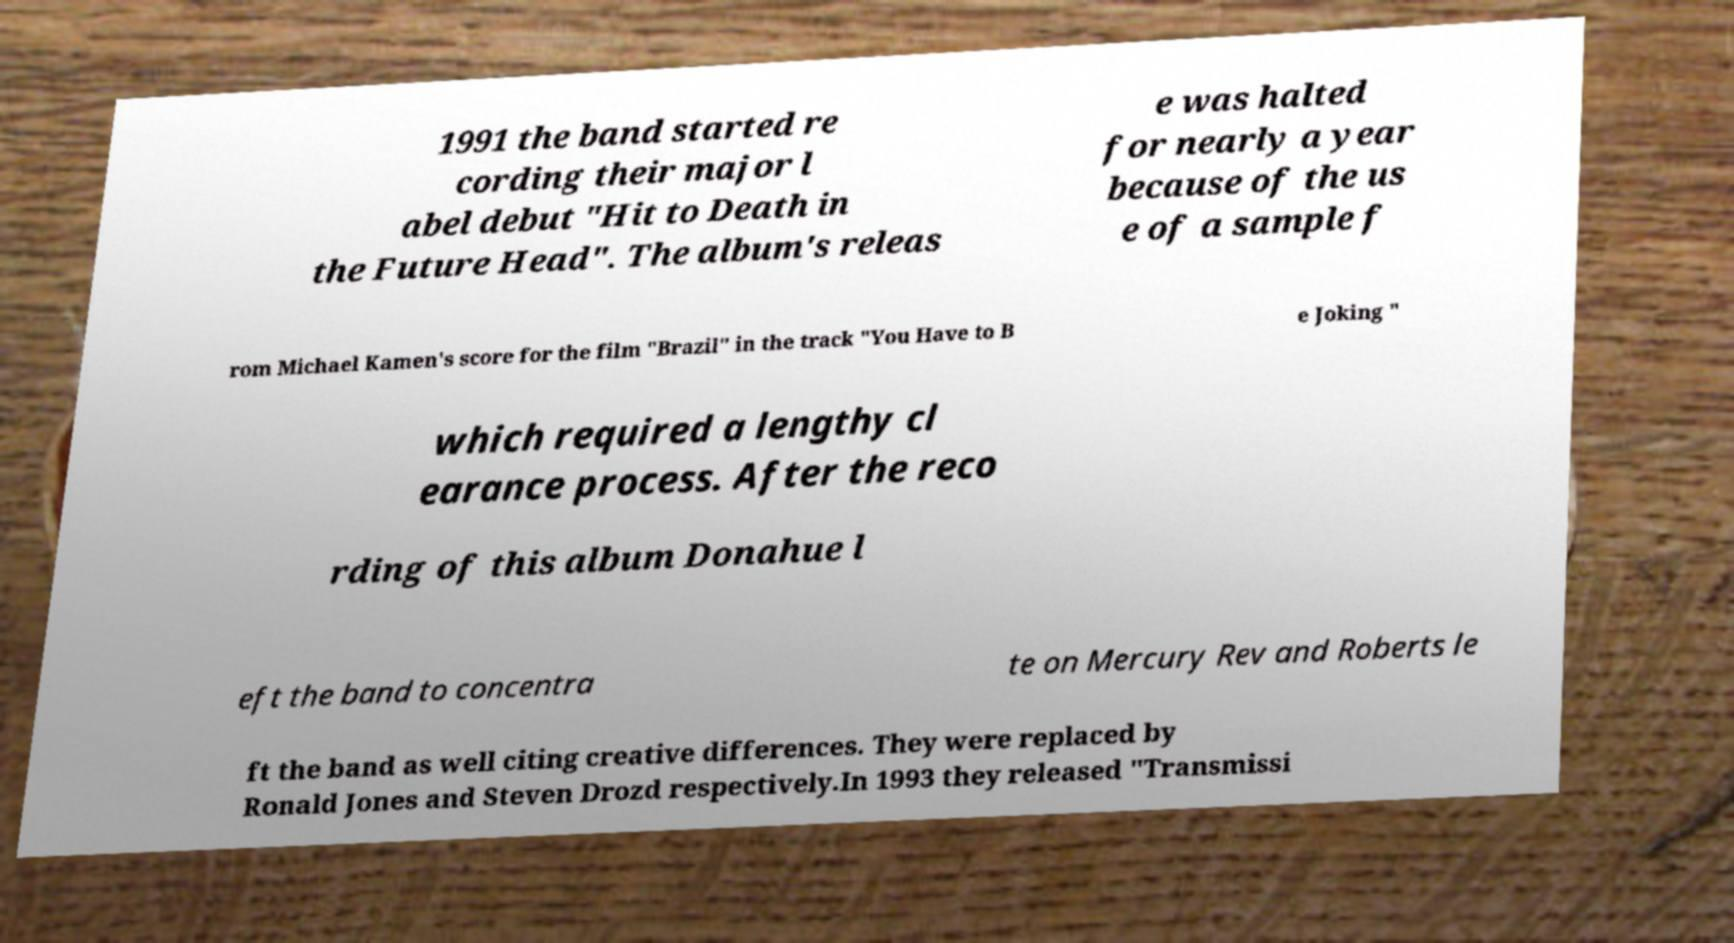Can you read and provide the text displayed in the image?This photo seems to have some interesting text. Can you extract and type it out for me? 1991 the band started re cording their major l abel debut "Hit to Death in the Future Head". The album's releas e was halted for nearly a year because of the us e of a sample f rom Michael Kamen's score for the film "Brazil" in the track "You Have to B e Joking " which required a lengthy cl earance process. After the reco rding of this album Donahue l eft the band to concentra te on Mercury Rev and Roberts le ft the band as well citing creative differences. They were replaced by Ronald Jones and Steven Drozd respectively.In 1993 they released "Transmissi 